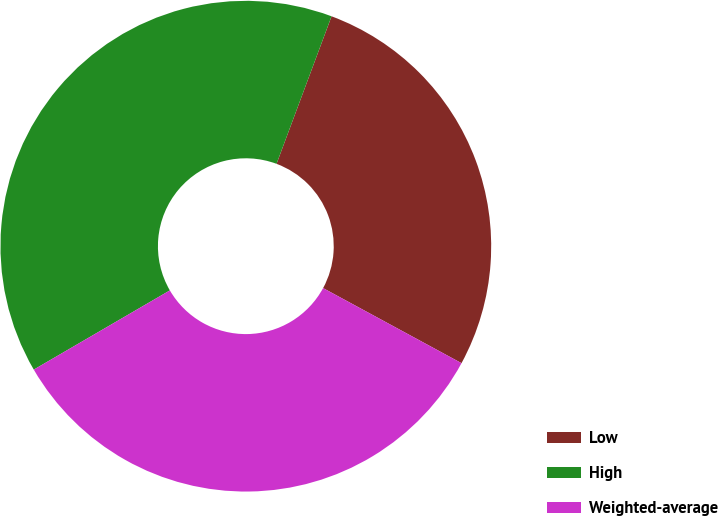<chart> <loc_0><loc_0><loc_500><loc_500><pie_chart><fcel>Low<fcel>High<fcel>Weighted-average<nl><fcel>27.23%<fcel>39.07%<fcel>33.7%<nl></chart> 